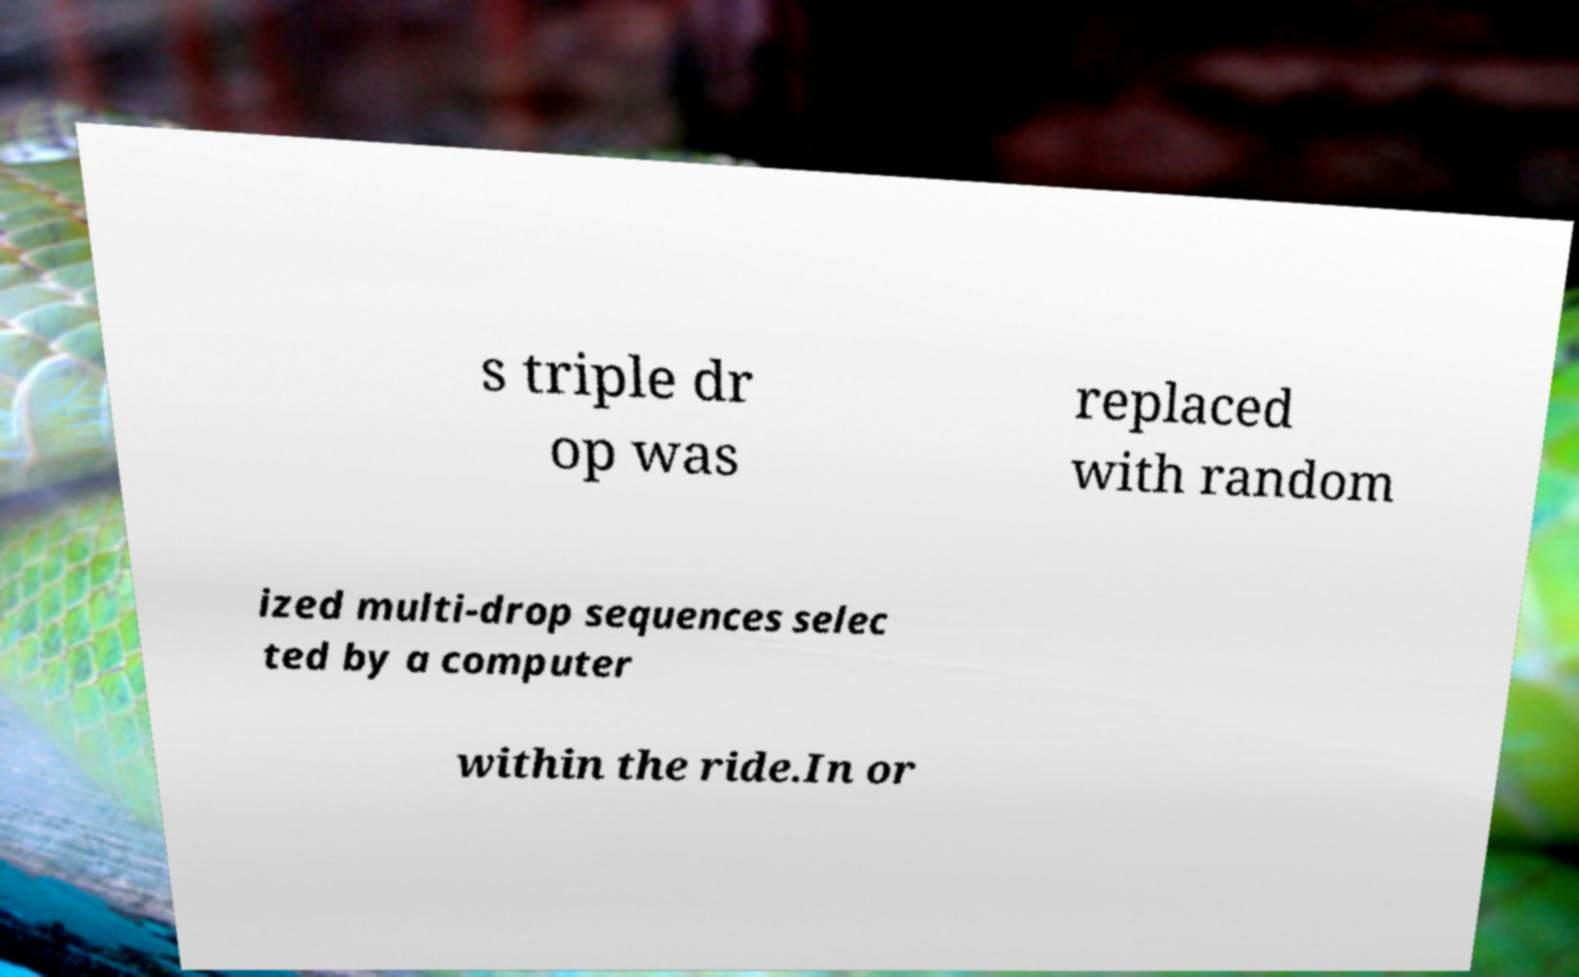Please identify and transcribe the text found in this image. s triple dr op was replaced with random ized multi-drop sequences selec ted by a computer within the ride.In or 